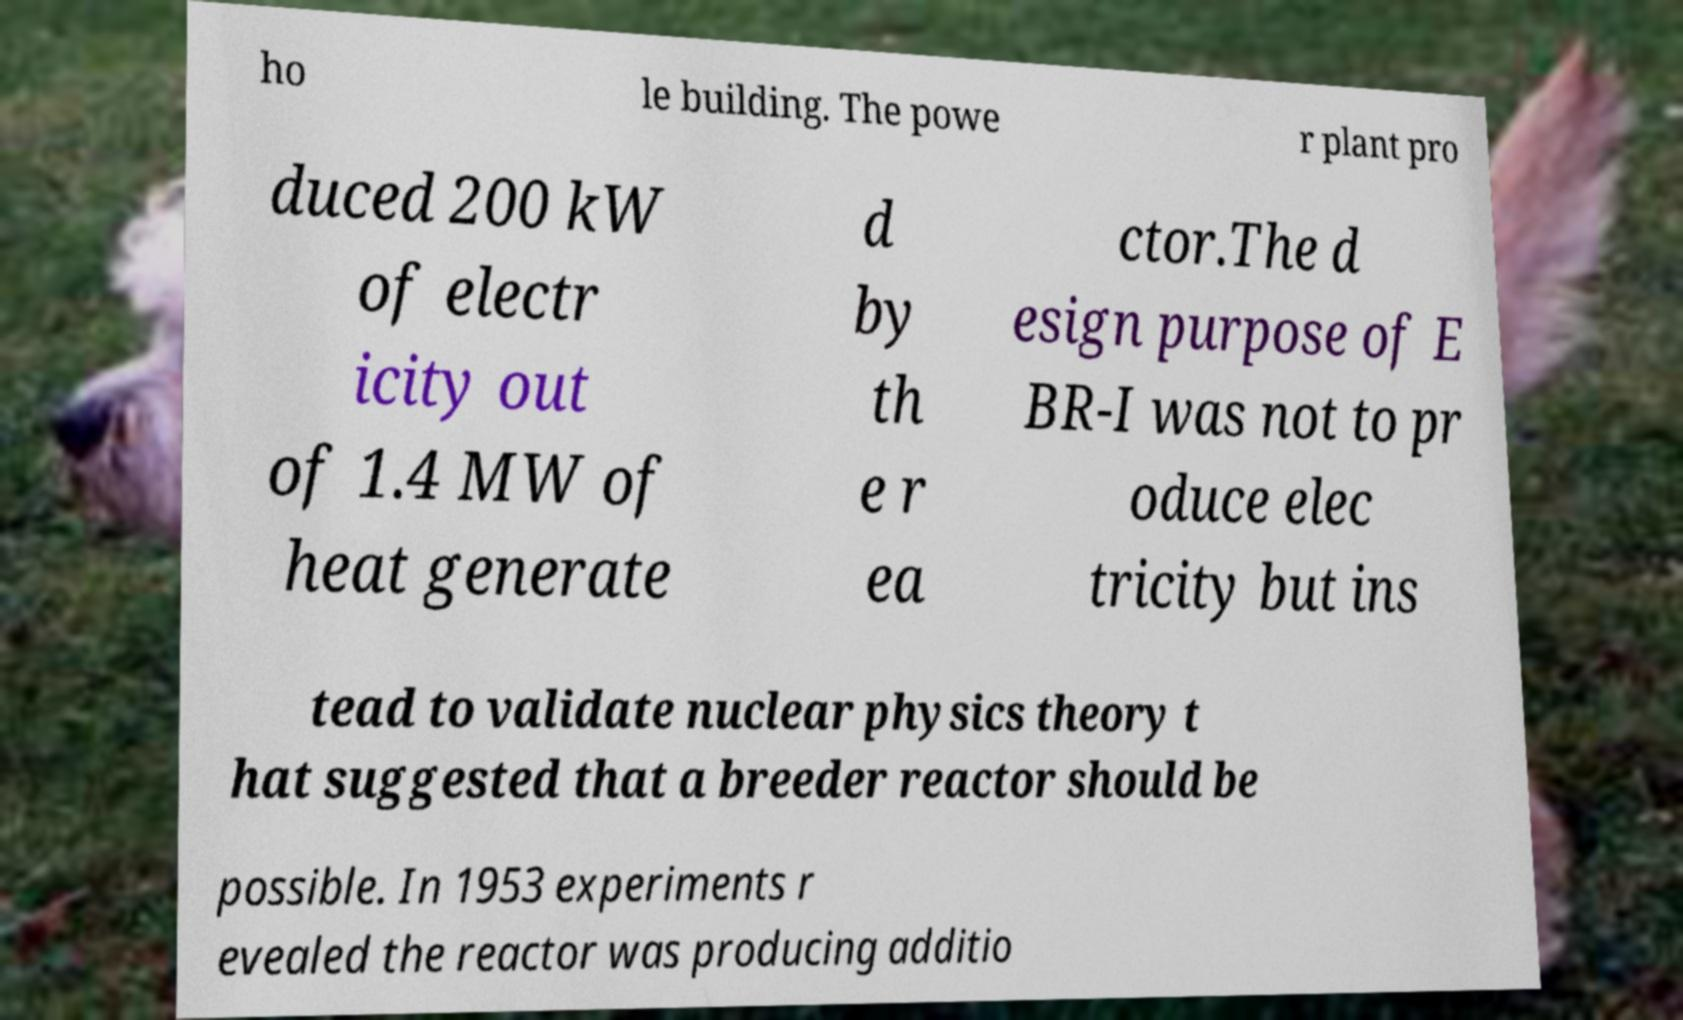I need the written content from this picture converted into text. Can you do that? ho le building. The powe r plant pro duced 200 kW of electr icity out of 1.4 MW of heat generate d by th e r ea ctor.The d esign purpose of E BR-I was not to pr oduce elec tricity but ins tead to validate nuclear physics theory t hat suggested that a breeder reactor should be possible. In 1953 experiments r evealed the reactor was producing additio 